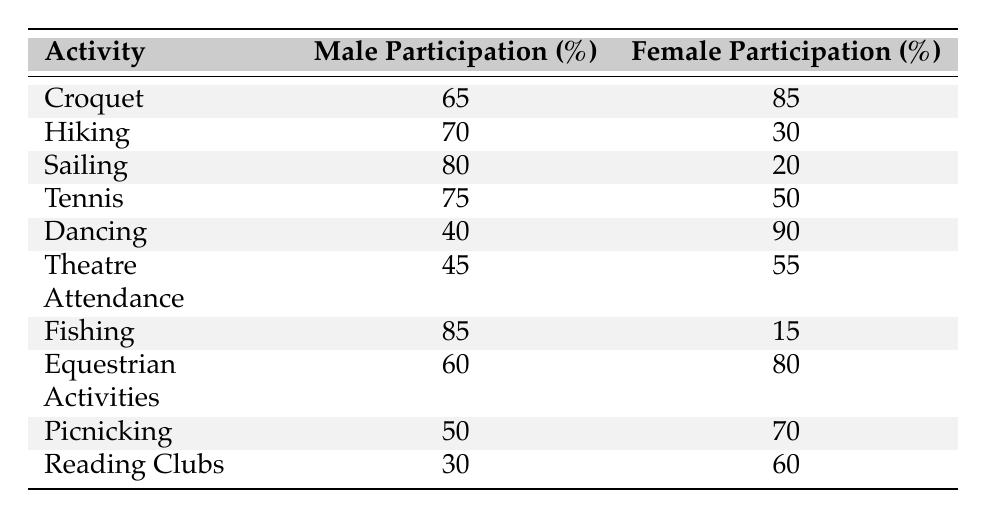What is the participation rate of females in Dancing? The table shows that the female participation rate in Dancing is listed as 90%.
Answer: 90% Which recreational activity has the highest male participation rate? By examining the male participation rates in the table, Fishing at 85% has the highest rate compared to other activities.
Answer: Fishing What is the difference between male and female participation rates in Hiking? The male participation rate in Hiking is 70% and female is 30%. The difference is calculated as 70% - 30% = 40%.
Answer: 40% Which activity has the lowest female participation rate? By looking at the female participation rates, Sailing has the lowest rate at 20%.
Answer: Sailing What is the combined male participation rate for Tennis and Theatre Attendance? The male participation rate for Tennis is 75% and for Theatre Attendance is 45%. Adding these gives 75% + 45% = 120%.
Answer: 120% Is male participation in Equestrian Activities higher than in Fishing? The male participation rate for Equestrian Activities is 60%, while it is 85% for Fishing. So, no, it is not higher.
Answer: No What is the average female participation rate across all activities? The female participation rates are 85%, 30%, 20%, 50%, 90%, 55%, 15%, 80%, 70%, and 60%. Adding these gives 85 + 30 + 20 + 50 + 90 + 55 + 15 + 80 + 70 + 60 =  650. Dividing by 10 gives an average of 65%.
Answer: 65% Which activity shows the widest gap between male and female participation rates? To find the widest gap, calculate the differences: Croquet (20%), Hiking (40%), Sailing (60%), Tennis (25%), Dancing (50%), Theatre Attendance (10%), Fishing (70%), Equestrian Activities (20%), Picnicking (20%), and Reading Clubs (30%). The largest gap is 70% in Fishing.
Answer: Fishing Do more females participate in Reading Clubs than males? The table shows a female participation rate of 60% in Reading Clubs and a male rate of 30%. Therefore, yes, more females participate.
Answer: Yes What is the combined female participation rate for Croquet, Tennis, and Picnicking? The female participation rates for Croquet (85%), Tennis (50%), and Picnicking (70%) sum to 85% + 50% + 70% = 205%.
Answer: 205% 